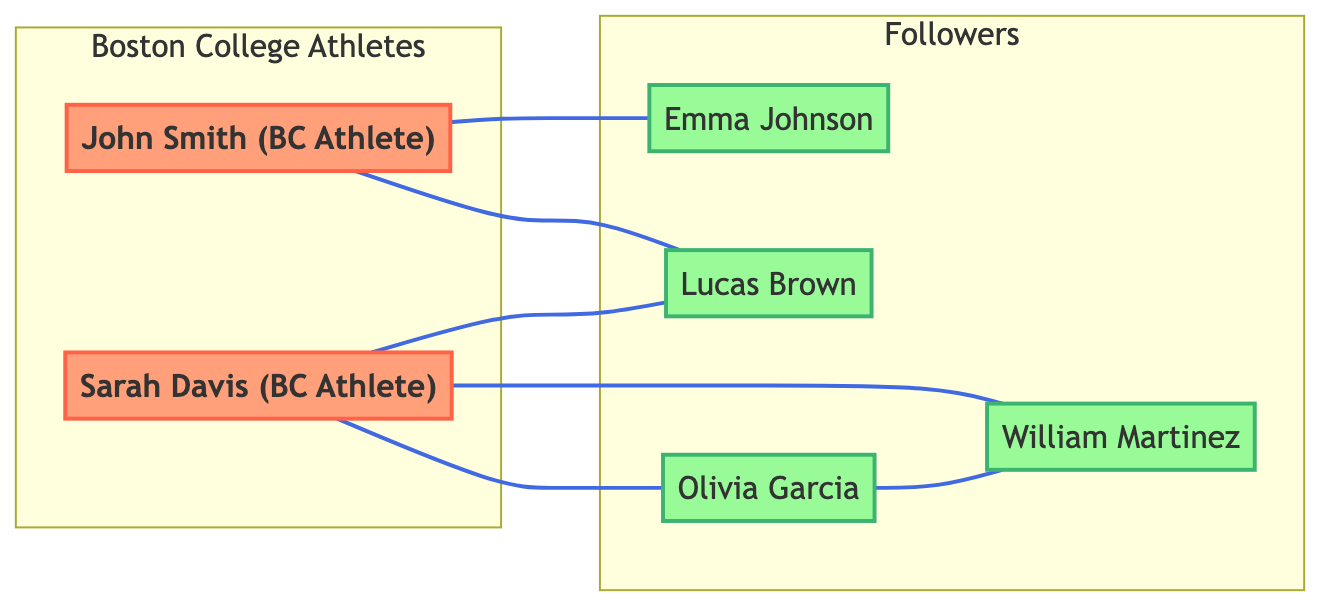How many Boston College athletes are represented in the graph? The graph shows two nodes labeled as Boston College Athletes: John Smith and Sarah Davis. Therefore, the count of Boston College athletes is 2.
Answer: 2 What is the connection type between John Smith and Emma Johnson? The edge connecting John Smith (athlete) and Emma Johnson (follower) is labeled "following," indicating a one-directional relationship where John Smith follows Emma Johnson.
Answer: following How many followers does Sarah Davis have? Sarah Davis has three connections in the graph: one with Lucas Brown and two with Olivia Garcia and William Martinez, meaning she follows all three followers. Therefore, she has 3 followers.
Answer: 3 Which follower is connected to both John Smith and Sarah Davis? Lucas Brown is the follower who has connections with both John Smith (follows him) and Sarah Davis (is followed by her), making him the common link.
Answer: Lucas Brown What is the total number of edges in the graph? By counting the edges that represent the following relationships, we find there are six edges: one for each connection among the athletes and followers. Hence, the total edges present is 6.
Answer: 6 Which follower has a mutual following relationship with another follower? The edge between Olivia Garcia and William Martinez is labeled as "mutual following," indicating that this relationship exists between these two followers.
Answer: Olivia Garcia How many total nodes are present in the graph? By identifying each unique node in the graph, we have six: two athletes and four followers, resulting in a total of 6 nodes.
Answer: 6 Which athlete has the most direct connections to followers? Sarah Davis has three direct following connections to her followers (Lucas Brown, Olivia Garcia, and William Martinez), which is the highest among the athletes.
Answer: Sarah Davis What type of graph is represented in this diagram? The graph shows undirected relationships between the athletes and their followers as there are connections without a specified directionality, indicating mutual connection points.
Answer: Undirected Graph 